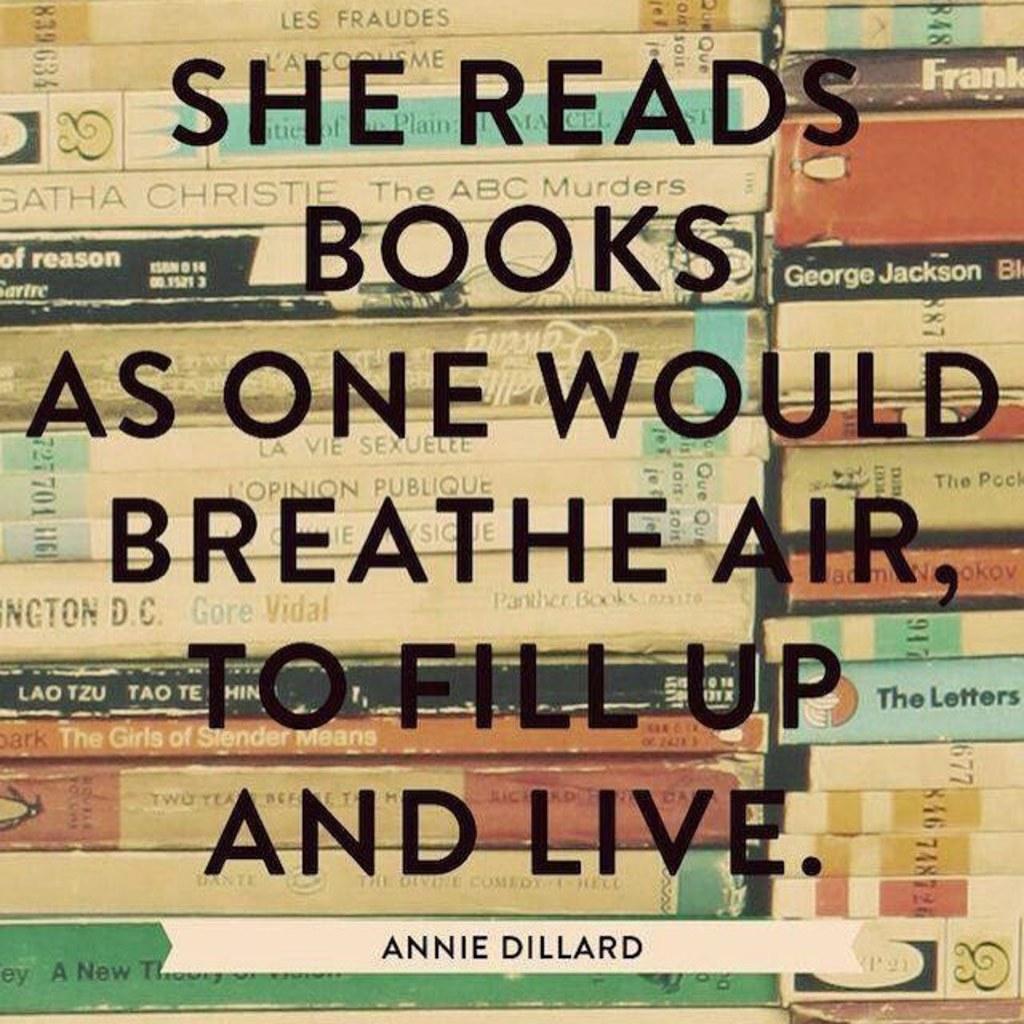Who is the author at the bottom?
Offer a very short reply. Annie dillard. What is the title of this book?
Make the answer very short. Unanswerable. 